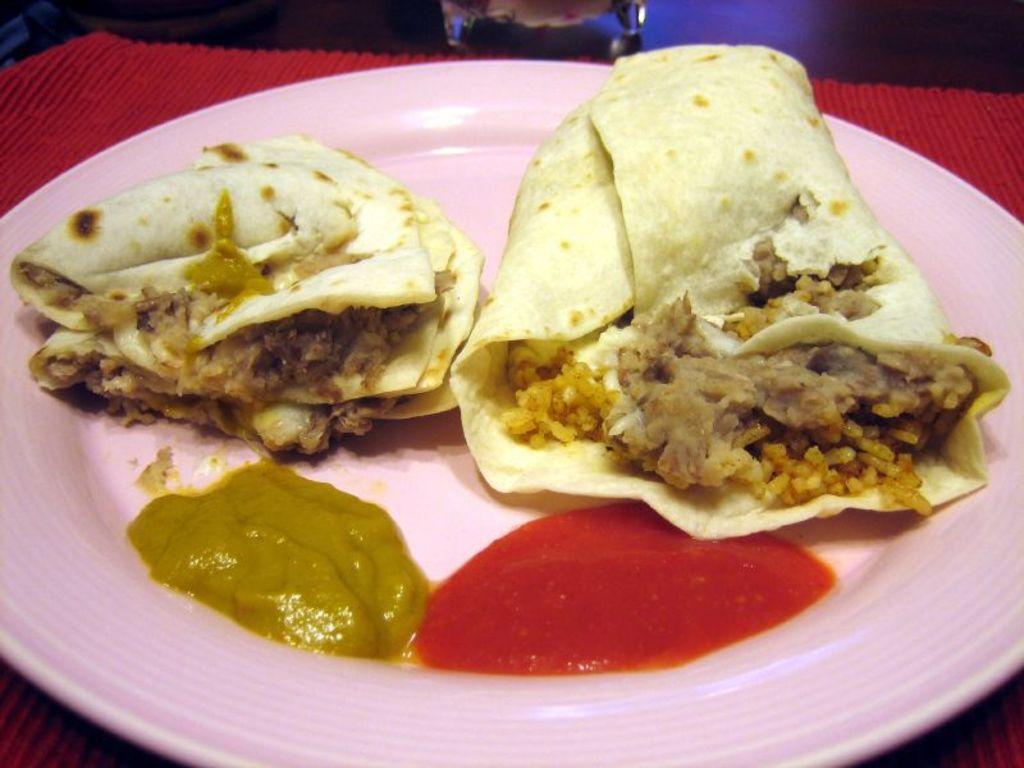How would you summarize this image in a sentence or two? In this picture, we can see a table, on that table, we can see a red color cloth and a plate. On that plate, we can see two rolls and a sauce. In the background, we can see a glass. 